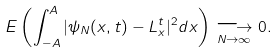Convert formula to latex. <formula><loc_0><loc_0><loc_500><loc_500>E \left ( \int _ { - A } ^ { A } | \psi _ { N } ( x , t ) - L _ { x } ^ { t } | ^ { 2 } d x \right ) \underset { N \to \infty } \longrightarrow 0 .</formula> 